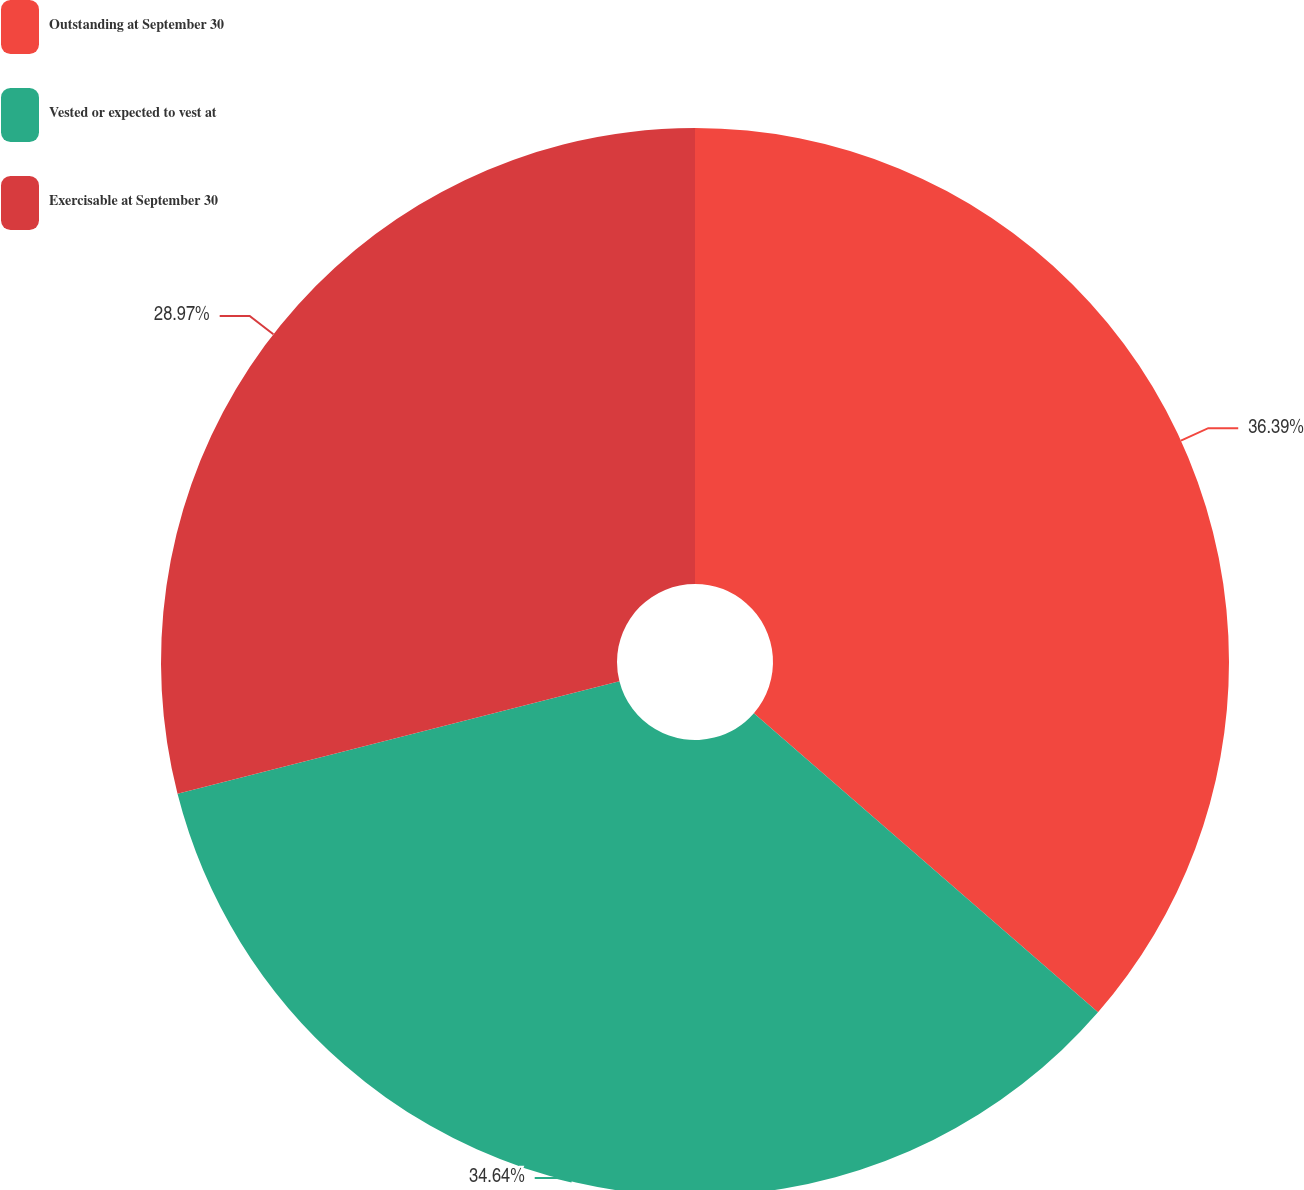<chart> <loc_0><loc_0><loc_500><loc_500><pie_chart><fcel>Outstanding at September 30<fcel>Vested or expected to vest at<fcel>Exercisable at September 30<nl><fcel>36.39%<fcel>34.64%<fcel>28.97%<nl></chart> 